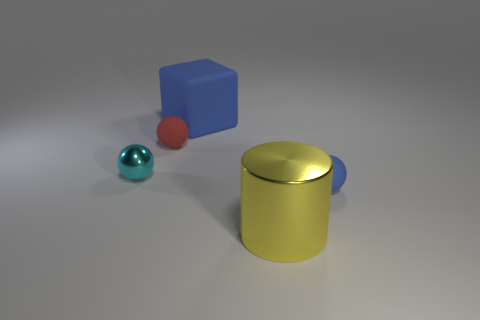Subtract all blue matte spheres. How many spheres are left? 2 Add 2 tiny metal things. How many objects exist? 7 Subtract all cylinders. How many objects are left? 4 Add 1 tiny blue balls. How many tiny blue balls are left? 2 Add 1 big blue cubes. How many big blue cubes exist? 2 Subtract 0 gray cylinders. How many objects are left? 5 Subtract all cyan balls. Subtract all blue cylinders. How many balls are left? 2 Subtract all brown things. Subtract all rubber spheres. How many objects are left? 3 